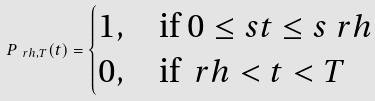Convert formula to latex. <formula><loc_0><loc_0><loc_500><loc_500>P _ { \ r h , T } ( t ) = \begin{cases} 1 , & \text {if } 0 \leq s t \leq s \ r h \\ 0 , & \text {if } \ r h < t < T \end{cases}</formula> 